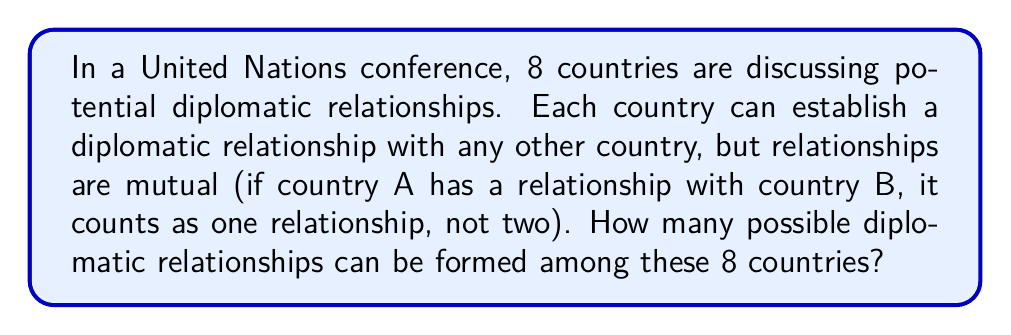Can you answer this question? To solve this problem, we need to understand that we're looking for combinations, not permutations, because the order doesn't matter (AB is the same as BA in this context).

1) First, we need to calculate how many pairs of countries can be formed from 8 countries. This is a combination problem.

2) The formula for combinations is:

   $$C(n,r) = \frac{n!}{r!(n-r)!}$$

   Where $n$ is the total number of items (in this case, 8 countries) and $r$ is the number of items being chosen at a time (in this case, 2, as we're forming pairs).

3) Plugging in our values:

   $$C(8,2) = \frac{8!}{2!(8-2)!} = \frac{8!}{2!(6)!}$$

4) Expanding this:

   $$\frac{8 * 7 * 6!}{2 * 1 * 6!}$$

5) The 6! cancels out in the numerator and denominator:

   $$\frac{8 * 7}{2 * 1} = \frac{56}{2} = 28$$

Therefore, there are 28 possible diplomatic relationships that can be formed among the 8 countries.

This problem integrates political science concepts (international relations and diplomacy) with mathematical combinations, demonstrating how these subjects can be interconnected in curriculum development.
Answer: 28 possible diplomatic relationships 